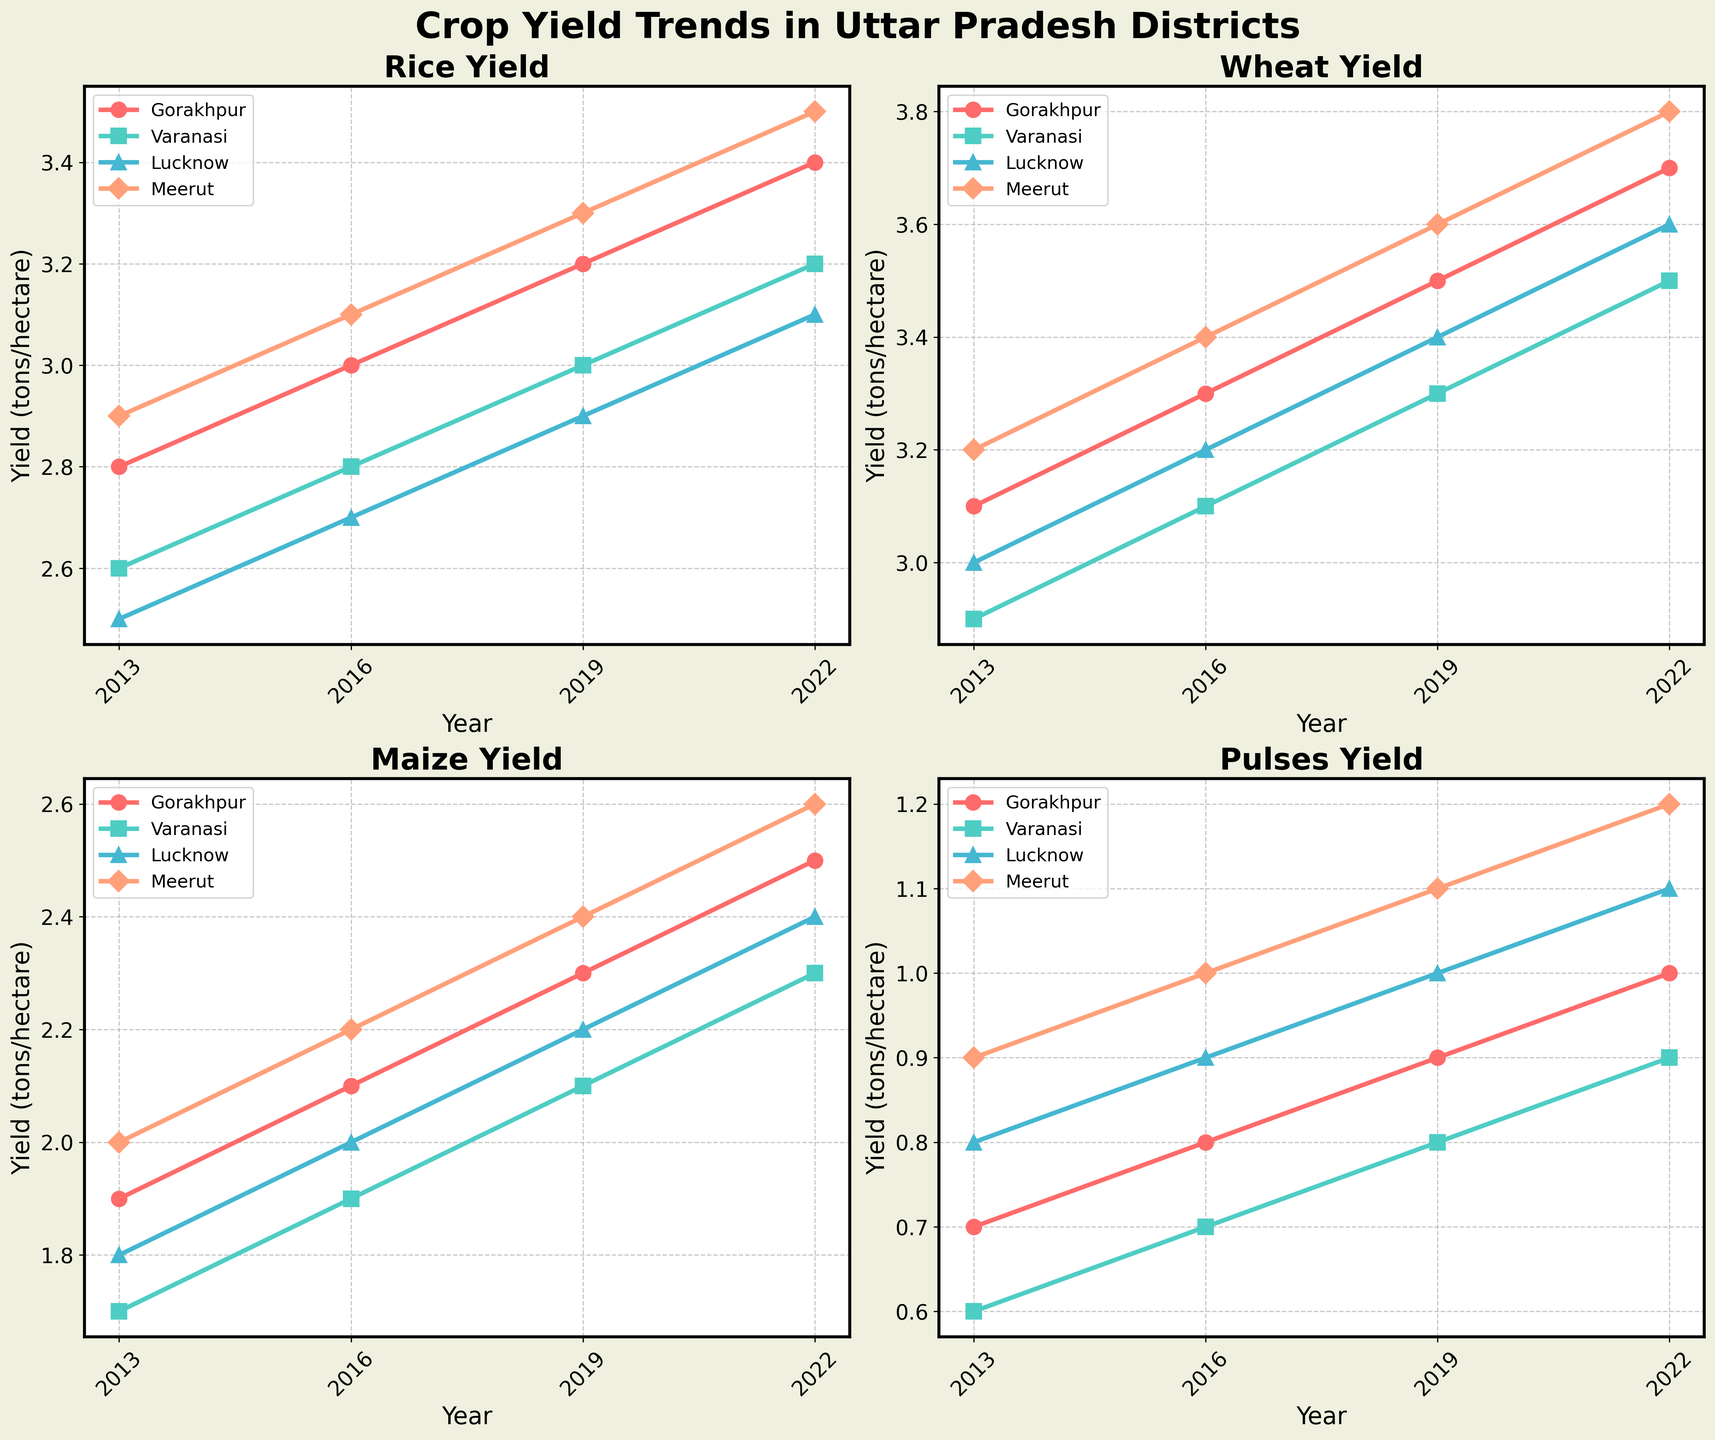What are the trends for rice yield in Meerut over the past decade? Look at the subplot for 'Rice Yield' and identify the line representing Meerut. Note its position at various data points spanning from 2013 to 2022 and observe whether it's increasing or decreasing.
Answer: The trend is increasing Which district had the highest wheat yield in 2022? Examine the subplot for 'Wheat Yield' and find the yield values for the year 2022 across all districts. Compare the values to determine the highest.
Answer: Meerut Between Gorakhpur and Lucknow, which district showed more increase in maize yield from 2013 to 2022? Refer to the 'Maize Yield' subplot and look at the yield values for Gorakhpur and Lucknow in 2013 and 2022. Calculate the difference for both districts and compare the values.
Answer: Gorakhpur How consistent has the pulses yield been in Varanasi over the years? Check the 'Pulses Yield' subplot and find the line representing Varanasi. Note the year-to-year changes in yield values to determine how much they vary.
Answer: Relatively consistent, with a slight increase What is the average rice yield in all districts for the year 2016? Look at the 'Rice Yield' subplot and find the 2016 values for each district. Sum these values and divide by the number of districts. (3.0 + 2.8 + 2.7 + 3.1) / 4 = 11.6 / 4
Answer: 2.9 Did the wheat yield in Varanasi ever surpass the wheat yield in Meerut in any given year? Compare the 'Wheat Yield' subplot for Varanasi and Meerut across all years. Check if at any point Varanasi's yield exceeded Meerut's yield.
Answer: No Which crop showed the most growth in yield in Gorakhpur from 2013 to 2022? Compare the changes in yield for all crops in the 'Gorakhpur' data across the years 2013 to 2022. Find the difference for each crop and compare.
Answer: Rice In 2019, which district had the lowest maize yield? Refer to the 'Maize Yield' subplot for the year 2019 and identify which district has the lowest value.
Answer: Varanasi What is the overall trend for wheat yield in Uttar Pradesh? Look at the 'Wheat Yield' subplots for all districts and observe the overall direction of the lines representing the yield from 2013 to 2022.
Answer: Increasing Compare the pulse yields in Meerut and Lucknow in 2022. Which district had a better yield? Refer to the 'Pulses Yield' subplot and check the values for Meerut and Lucknow in the year 2022. Compare the values directly.
Answer: Meerut 